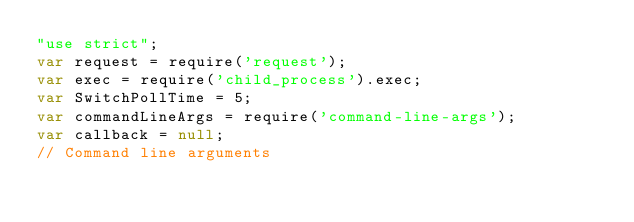Convert code to text. <code><loc_0><loc_0><loc_500><loc_500><_JavaScript_>"use strict";
var request = require('request');
var exec = require('child_process').exec;
var SwitchPollTime = 5;
var commandLineArgs = require('command-line-args');
var callback = null;
// Command line arguments</code> 